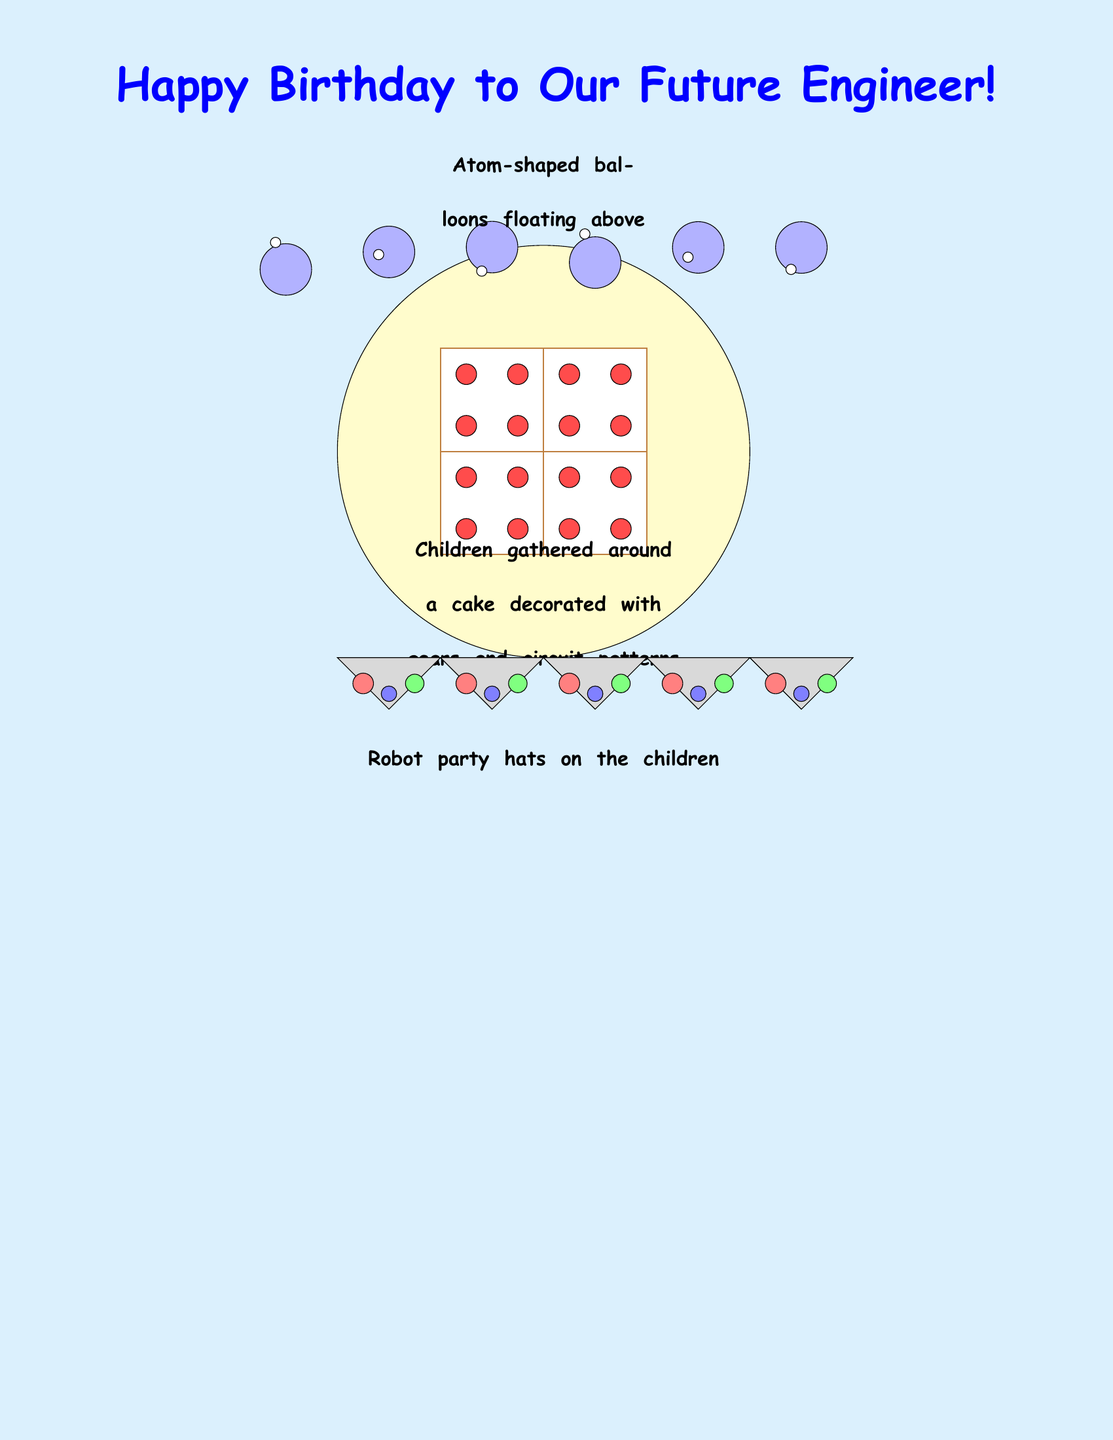What is the theme of the birthday card? The theme is celebrating a child's future in engineering, as indicated by the cover and inside content.
Answer: Future Engineer How many fun facts are listed in the document? The document contains three fun facts about engineering and inventions.
Answer: Three Who invented the microwave oven? The document mentions Percy Spencer as the inventor of the microwave oven by accident.
Answer: Percy Spencer What is one activity mentioned that children are doing in the cover illustration? The children are gathered around a cake that is decorated with gears and circuit patterns, as described in the illustration.
Answer: Gathered around a cake What kind of balloons are depicted in the cover illustration? The balloons are described as atom-shaped, which reflects a science theme.
Answer: Atom-shaped What is a unique feature of the longest bridge mentioned? The longest bridge is noted to span 102.4 miles, which is a specific measurement given in the fun facts.
Answer: 102.4 miles How does the card suggest engineers contribute to parties? The card states that engineers make great party guests because they bring ideas to life, indicating their creativity.
Answer: Bring ideas to life What is one of the quotes included in the card? The document features quotes about engineering, one being by Theodore von Kármán.
Answer: "Scientists study the world as it is; engineers create the world that has never been." What color is the inside of the card? The inside of the card uses a green color scheme, specifically an inside green that is lighter in shade.
Answer: Green What type of hats are the children wearing? The children are wearing robot party hats, which fits the engineering theme of the card.
Answer: Robot party hats 